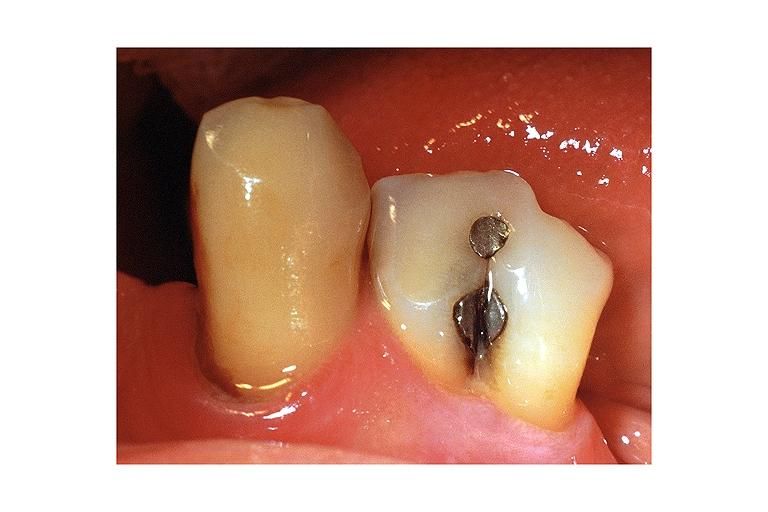what does this image show?
Answer the question using a single word or phrase. Fusion 